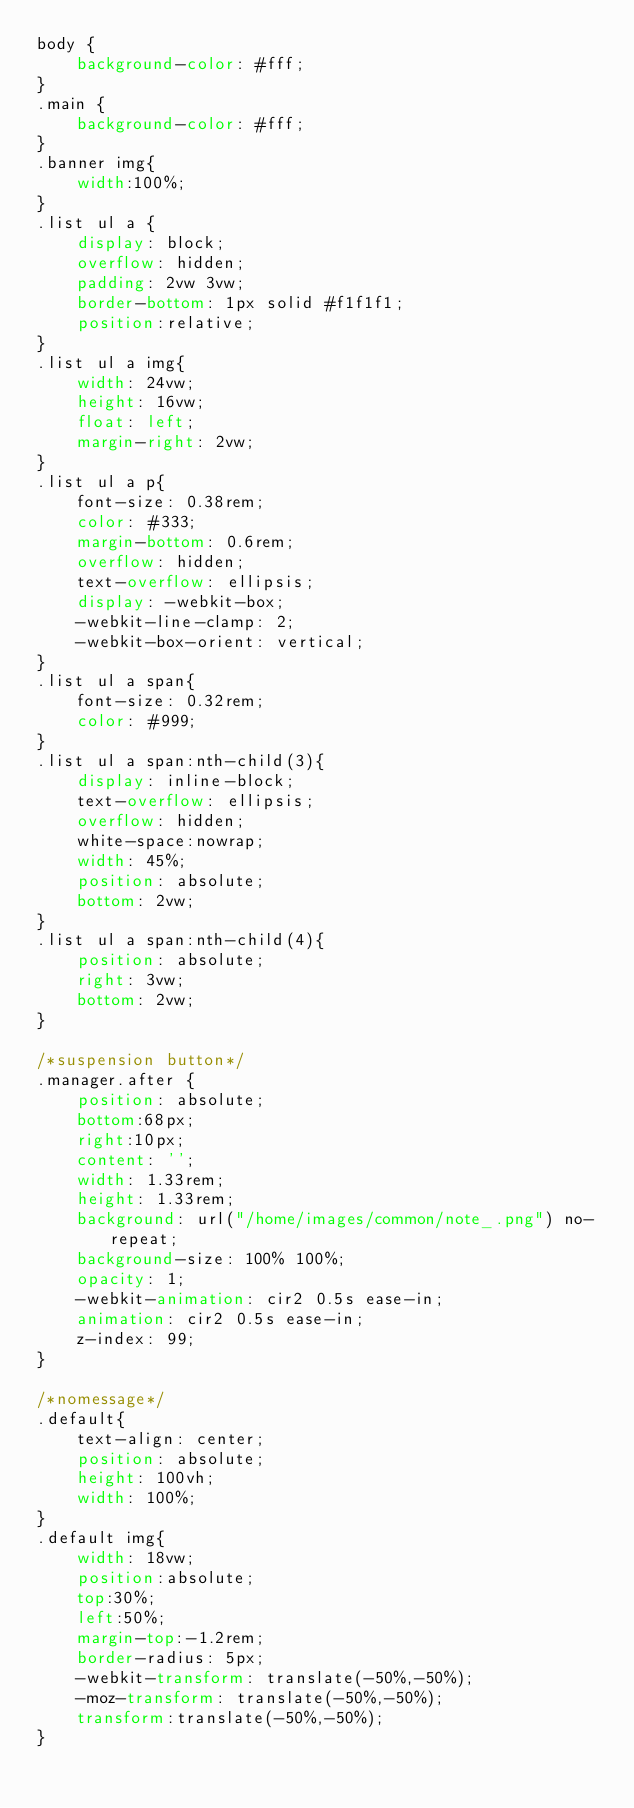<code> <loc_0><loc_0><loc_500><loc_500><_CSS_>body {
    background-color: #fff;
}
.main {
    background-color: #fff;
}
.banner img{
    width:100%;
}
.list ul a {
    display: block;
    overflow: hidden;
    padding: 2vw 3vw;
    border-bottom: 1px solid #f1f1f1;
    position:relative;
}
.list ul a img{
    width: 24vw;
    height: 16vw;
    float: left;
    margin-right: 2vw;
}
.list ul a p{
    font-size: 0.38rem;
    color: #333;
    margin-bottom: 0.6rem;
    overflow: hidden;
    text-overflow: ellipsis;
    display: -webkit-box;
    -webkit-line-clamp: 2;
    -webkit-box-orient: vertical;
}
.list ul a span{
    font-size: 0.32rem;
    color: #999;
}
.list ul a span:nth-child(3){
    display: inline-block;
    text-overflow: ellipsis;
    overflow: hidden;
    white-space:nowrap;
    width: 45%;
    position: absolute;
    bottom: 2vw;
}
.list ul a span:nth-child(4){
    position: absolute;
    right: 3vw;
    bottom: 2vw;
}

/*suspension button*/
.manager.after {
    position: absolute;
    bottom:68px;
    right:10px;
    content: '';
    width: 1.33rem;
    height: 1.33rem;
    background: url("/home/images/common/note_.png") no-repeat;
    background-size: 100% 100%;
    opacity: 1;
    -webkit-animation: cir2 0.5s ease-in;
    animation: cir2 0.5s ease-in;
    z-index: 99;
}

/*nomessage*/
.default{
    text-align: center;
    position: absolute;
    height: 100vh;
    width: 100%;
}
.default img{
    width: 18vw;
    position:absolute;
    top:30%;
    left:50%;
    margin-top:-1.2rem;
    border-radius: 5px;
    -webkit-transform: translate(-50%,-50%);
    -moz-transform: translate(-50%,-50%);
    transform:translate(-50%,-50%);
}</code> 